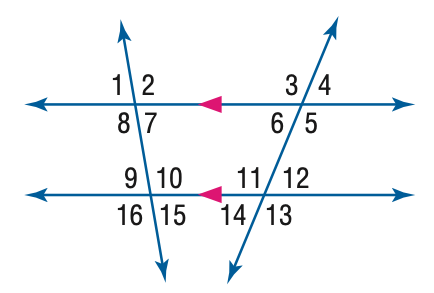Question: In the figure, m \angle 8 = 96 and m \angle 12 = 42. Find the measure of \angle 6.
Choices:
A. 42
B. 48
C. 84
D. 96
Answer with the letter. Answer: A Question: In the figure, m \angle 8 = 96 and m \angle 12 = 42. Find the measure of \angle 9.
Choices:
A. 42
B. 84
C. 94
D. 96
Answer with the letter. Answer: B 